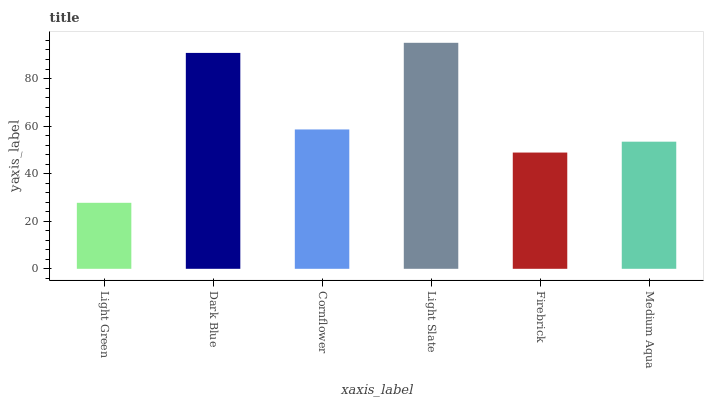Is Light Green the minimum?
Answer yes or no. Yes. Is Light Slate the maximum?
Answer yes or no. Yes. Is Dark Blue the minimum?
Answer yes or no. No. Is Dark Blue the maximum?
Answer yes or no. No. Is Dark Blue greater than Light Green?
Answer yes or no. Yes. Is Light Green less than Dark Blue?
Answer yes or no. Yes. Is Light Green greater than Dark Blue?
Answer yes or no. No. Is Dark Blue less than Light Green?
Answer yes or no. No. Is Cornflower the high median?
Answer yes or no. Yes. Is Medium Aqua the low median?
Answer yes or no. Yes. Is Dark Blue the high median?
Answer yes or no. No. Is Dark Blue the low median?
Answer yes or no. No. 